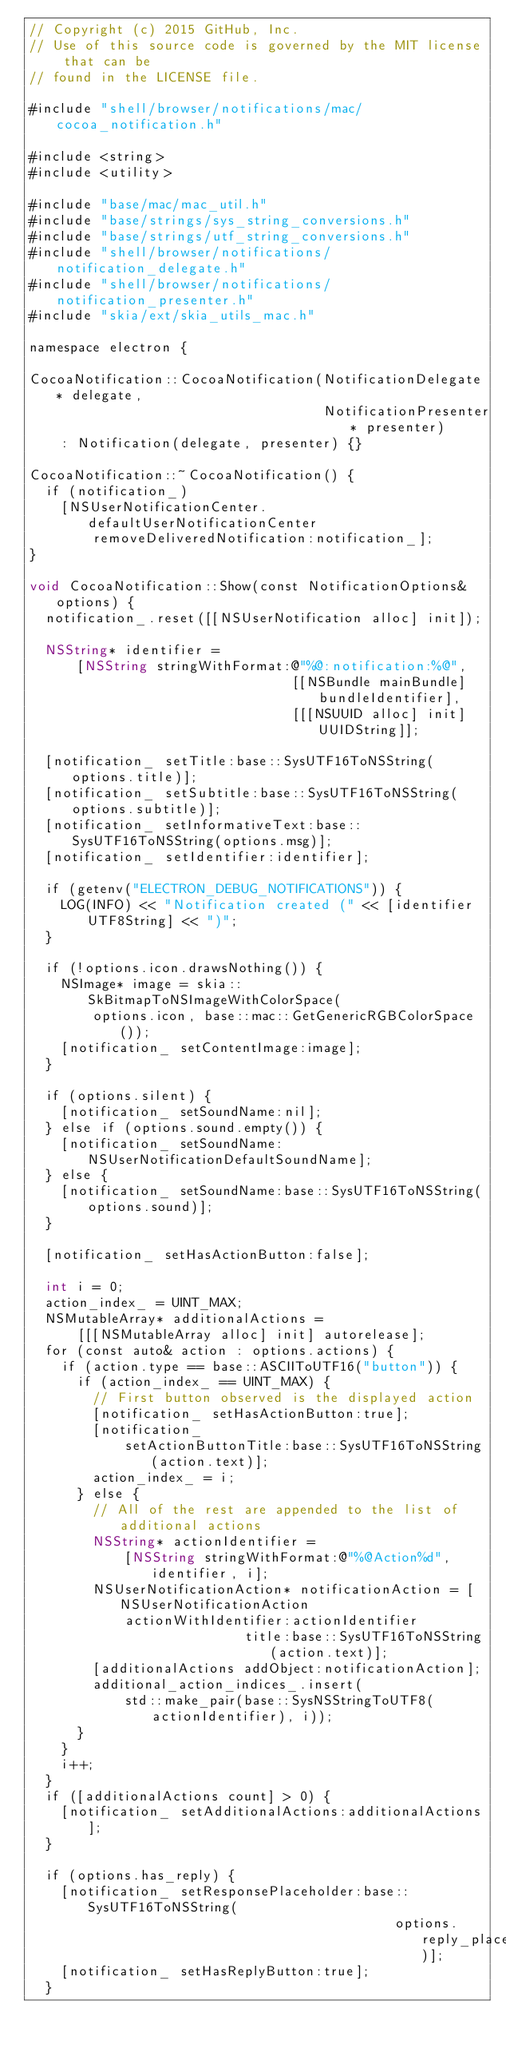Convert code to text. <code><loc_0><loc_0><loc_500><loc_500><_ObjectiveC_>// Copyright (c) 2015 GitHub, Inc.
// Use of this source code is governed by the MIT license that can be
// found in the LICENSE file.

#include "shell/browser/notifications/mac/cocoa_notification.h"

#include <string>
#include <utility>

#include "base/mac/mac_util.h"
#include "base/strings/sys_string_conversions.h"
#include "base/strings/utf_string_conversions.h"
#include "shell/browser/notifications/notification_delegate.h"
#include "shell/browser/notifications/notification_presenter.h"
#include "skia/ext/skia_utils_mac.h"

namespace electron {

CocoaNotification::CocoaNotification(NotificationDelegate* delegate,
                                     NotificationPresenter* presenter)
    : Notification(delegate, presenter) {}

CocoaNotification::~CocoaNotification() {
  if (notification_)
    [NSUserNotificationCenter.defaultUserNotificationCenter
        removeDeliveredNotification:notification_];
}

void CocoaNotification::Show(const NotificationOptions& options) {
  notification_.reset([[NSUserNotification alloc] init]);

  NSString* identifier =
      [NSString stringWithFormat:@"%@:notification:%@",
                                 [[NSBundle mainBundle] bundleIdentifier],
                                 [[[NSUUID alloc] init] UUIDString]];

  [notification_ setTitle:base::SysUTF16ToNSString(options.title)];
  [notification_ setSubtitle:base::SysUTF16ToNSString(options.subtitle)];
  [notification_ setInformativeText:base::SysUTF16ToNSString(options.msg)];
  [notification_ setIdentifier:identifier];

  if (getenv("ELECTRON_DEBUG_NOTIFICATIONS")) {
    LOG(INFO) << "Notification created (" << [identifier UTF8String] << ")";
  }

  if (!options.icon.drawsNothing()) {
    NSImage* image = skia::SkBitmapToNSImageWithColorSpace(
        options.icon, base::mac::GetGenericRGBColorSpace());
    [notification_ setContentImage:image];
  }

  if (options.silent) {
    [notification_ setSoundName:nil];
  } else if (options.sound.empty()) {
    [notification_ setSoundName:NSUserNotificationDefaultSoundName];
  } else {
    [notification_ setSoundName:base::SysUTF16ToNSString(options.sound)];
  }

  [notification_ setHasActionButton:false];

  int i = 0;
  action_index_ = UINT_MAX;
  NSMutableArray* additionalActions =
      [[[NSMutableArray alloc] init] autorelease];
  for (const auto& action : options.actions) {
    if (action.type == base::ASCIIToUTF16("button")) {
      if (action_index_ == UINT_MAX) {
        // First button observed is the displayed action
        [notification_ setHasActionButton:true];
        [notification_
            setActionButtonTitle:base::SysUTF16ToNSString(action.text)];
        action_index_ = i;
      } else {
        // All of the rest are appended to the list of additional actions
        NSString* actionIdentifier =
            [NSString stringWithFormat:@"%@Action%d", identifier, i];
        NSUserNotificationAction* notificationAction = [NSUserNotificationAction
            actionWithIdentifier:actionIdentifier
                           title:base::SysUTF16ToNSString(action.text)];
        [additionalActions addObject:notificationAction];
        additional_action_indices_.insert(
            std::make_pair(base::SysNSStringToUTF8(actionIdentifier), i));
      }
    }
    i++;
  }
  if ([additionalActions count] > 0) {
    [notification_ setAdditionalActions:additionalActions];
  }

  if (options.has_reply) {
    [notification_ setResponsePlaceholder:base::SysUTF16ToNSString(
                                              options.reply_placeholder)];
    [notification_ setHasReplyButton:true];
  }
</code> 